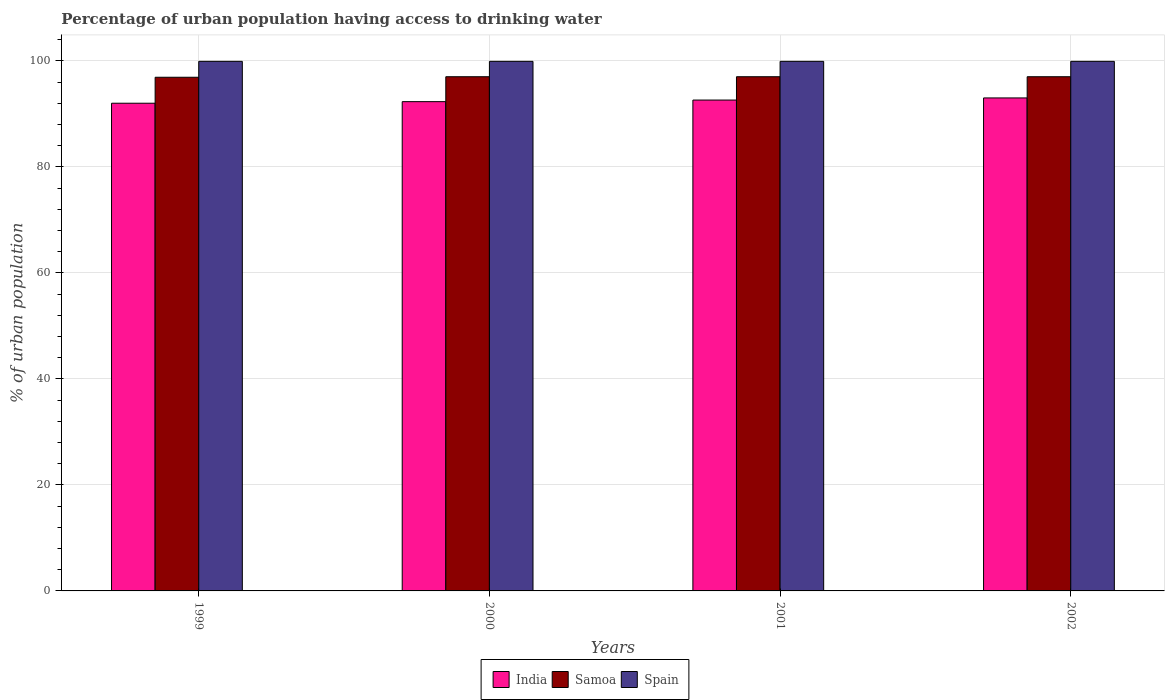How many groups of bars are there?
Your answer should be very brief. 4. How many bars are there on the 3rd tick from the left?
Provide a short and direct response. 3. What is the label of the 3rd group of bars from the left?
Make the answer very short. 2001. What is the percentage of urban population having access to drinking water in India in 2001?
Ensure brevity in your answer.  92.6. Across all years, what is the maximum percentage of urban population having access to drinking water in Spain?
Make the answer very short. 99.9. Across all years, what is the minimum percentage of urban population having access to drinking water in Spain?
Offer a very short reply. 99.9. What is the total percentage of urban population having access to drinking water in Samoa in the graph?
Offer a very short reply. 387.9. What is the difference between the percentage of urban population having access to drinking water in India in 2000 and that in 2002?
Keep it short and to the point. -0.7. What is the difference between the percentage of urban population having access to drinking water in Samoa in 2000 and the percentage of urban population having access to drinking water in Spain in 2002?
Keep it short and to the point. -2.9. What is the average percentage of urban population having access to drinking water in India per year?
Provide a short and direct response. 92.47. In the year 2000, what is the difference between the percentage of urban population having access to drinking water in Samoa and percentage of urban population having access to drinking water in India?
Give a very brief answer. 4.7. What is the ratio of the percentage of urban population having access to drinking water in Spain in 2000 to that in 2002?
Ensure brevity in your answer.  1. Is the percentage of urban population having access to drinking water in Samoa in 2000 less than that in 2002?
Ensure brevity in your answer.  No. Is the difference between the percentage of urban population having access to drinking water in Samoa in 1999 and 2000 greater than the difference between the percentage of urban population having access to drinking water in India in 1999 and 2000?
Ensure brevity in your answer.  Yes. What does the 2nd bar from the right in 2001 represents?
Keep it short and to the point. Samoa. Is it the case that in every year, the sum of the percentage of urban population having access to drinking water in India and percentage of urban population having access to drinking water in Spain is greater than the percentage of urban population having access to drinking water in Samoa?
Offer a terse response. Yes. How many bars are there?
Your response must be concise. 12. How many years are there in the graph?
Make the answer very short. 4. Does the graph contain any zero values?
Your answer should be compact. No. Does the graph contain grids?
Your answer should be compact. Yes. How many legend labels are there?
Make the answer very short. 3. How are the legend labels stacked?
Your response must be concise. Horizontal. What is the title of the graph?
Offer a very short reply. Percentage of urban population having access to drinking water. Does "Sierra Leone" appear as one of the legend labels in the graph?
Give a very brief answer. No. What is the label or title of the X-axis?
Make the answer very short. Years. What is the label or title of the Y-axis?
Keep it short and to the point. % of urban population. What is the % of urban population of India in 1999?
Your response must be concise. 92. What is the % of urban population of Samoa in 1999?
Make the answer very short. 96.9. What is the % of urban population in Spain in 1999?
Make the answer very short. 99.9. What is the % of urban population of India in 2000?
Offer a terse response. 92.3. What is the % of urban population of Samoa in 2000?
Make the answer very short. 97. What is the % of urban population in Spain in 2000?
Make the answer very short. 99.9. What is the % of urban population of India in 2001?
Ensure brevity in your answer.  92.6. What is the % of urban population of Samoa in 2001?
Your response must be concise. 97. What is the % of urban population in Spain in 2001?
Your answer should be very brief. 99.9. What is the % of urban population of India in 2002?
Make the answer very short. 93. What is the % of urban population in Samoa in 2002?
Your response must be concise. 97. What is the % of urban population of Spain in 2002?
Your answer should be very brief. 99.9. Across all years, what is the maximum % of urban population of India?
Offer a very short reply. 93. Across all years, what is the maximum % of urban population of Samoa?
Offer a terse response. 97. Across all years, what is the maximum % of urban population in Spain?
Your answer should be compact. 99.9. Across all years, what is the minimum % of urban population of India?
Keep it short and to the point. 92. Across all years, what is the minimum % of urban population of Samoa?
Provide a succinct answer. 96.9. Across all years, what is the minimum % of urban population in Spain?
Offer a very short reply. 99.9. What is the total % of urban population in India in the graph?
Provide a succinct answer. 369.9. What is the total % of urban population in Samoa in the graph?
Your answer should be very brief. 387.9. What is the total % of urban population of Spain in the graph?
Your response must be concise. 399.6. What is the difference between the % of urban population of Spain in 1999 and that in 2000?
Provide a short and direct response. 0. What is the difference between the % of urban population of Samoa in 1999 and that in 2001?
Your response must be concise. -0.1. What is the difference between the % of urban population of India in 1999 and that in 2002?
Your answer should be very brief. -1. What is the difference between the % of urban population of Spain in 1999 and that in 2002?
Your response must be concise. 0. What is the difference between the % of urban population of Samoa in 2000 and that in 2001?
Your response must be concise. 0. What is the difference between the % of urban population in India in 2000 and that in 2002?
Your response must be concise. -0.7. What is the difference between the % of urban population of Samoa in 2000 and that in 2002?
Keep it short and to the point. 0. What is the difference between the % of urban population of Spain in 2000 and that in 2002?
Keep it short and to the point. 0. What is the difference between the % of urban population of Spain in 2001 and that in 2002?
Your response must be concise. 0. What is the difference between the % of urban population of India in 1999 and the % of urban population of Spain in 2000?
Offer a terse response. -7.9. What is the difference between the % of urban population of India in 1999 and the % of urban population of Spain in 2001?
Keep it short and to the point. -7.9. What is the difference between the % of urban population in India in 2000 and the % of urban population in Samoa in 2002?
Give a very brief answer. -4.7. What is the difference between the % of urban population of India in 2000 and the % of urban population of Spain in 2002?
Offer a very short reply. -7.6. What is the difference between the % of urban population in Samoa in 2000 and the % of urban population in Spain in 2002?
Offer a terse response. -2.9. What is the difference between the % of urban population in India in 2001 and the % of urban population in Spain in 2002?
Your response must be concise. -7.3. What is the average % of urban population of India per year?
Keep it short and to the point. 92.47. What is the average % of urban population of Samoa per year?
Your answer should be very brief. 96.97. What is the average % of urban population of Spain per year?
Your response must be concise. 99.9. In the year 1999, what is the difference between the % of urban population in India and % of urban population in Samoa?
Your answer should be compact. -4.9. In the year 1999, what is the difference between the % of urban population in India and % of urban population in Spain?
Offer a very short reply. -7.9. In the year 2000, what is the difference between the % of urban population in India and % of urban population in Spain?
Ensure brevity in your answer.  -7.6. In the year 2001, what is the difference between the % of urban population of India and % of urban population of Samoa?
Give a very brief answer. -4.4. In the year 2001, what is the difference between the % of urban population of India and % of urban population of Spain?
Ensure brevity in your answer.  -7.3. In the year 2001, what is the difference between the % of urban population in Samoa and % of urban population in Spain?
Ensure brevity in your answer.  -2.9. In the year 2002, what is the difference between the % of urban population of India and % of urban population of Spain?
Provide a succinct answer. -6.9. What is the ratio of the % of urban population in Samoa in 1999 to that in 2000?
Your answer should be compact. 1. What is the ratio of the % of urban population of Spain in 1999 to that in 2000?
Offer a terse response. 1. What is the ratio of the % of urban population of India in 1999 to that in 2001?
Provide a short and direct response. 0.99. What is the ratio of the % of urban population of Samoa in 1999 to that in 2001?
Offer a terse response. 1. What is the ratio of the % of urban population of India in 1999 to that in 2002?
Keep it short and to the point. 0.99. What is the ratio of the % of urban population in Spain in 1999 to that in 2002?
Provide a short and direct response. 1. What is the ratio of the % of urban population of Samoa in 2000 to that in 2002?
Offer a very short reply. 1. What is the ratio of the % of urban population of Spain in 2000 to that in 2002?
Provide a succinct answer. 1. What is the ratio of the % of urban population of India in 2001 to that in 2002?
Your answer should be very brief. 1. What is the ratio of the % of urban population of Samoa in 2001 to that in 2002?
Offer a very short reply. 1. What is the ratio of the % of urban population of Spain in 2001 to that in 2002?
Offer a very short reply. 1. What is the difference between the highest and the second highest % of urban population in India?
Offer a terse response. 0.4. What is the difference between the highest and the second highest % of urban population of Spain?
Your answer should be compact. 0. What is the difference between the highest and the lowest % of urban population of Samoa?
Offer a very short reply. 0.1. What is the difference between the highest and the lowest % of urban population in Spain?
Keep it short and to the point. 0. 